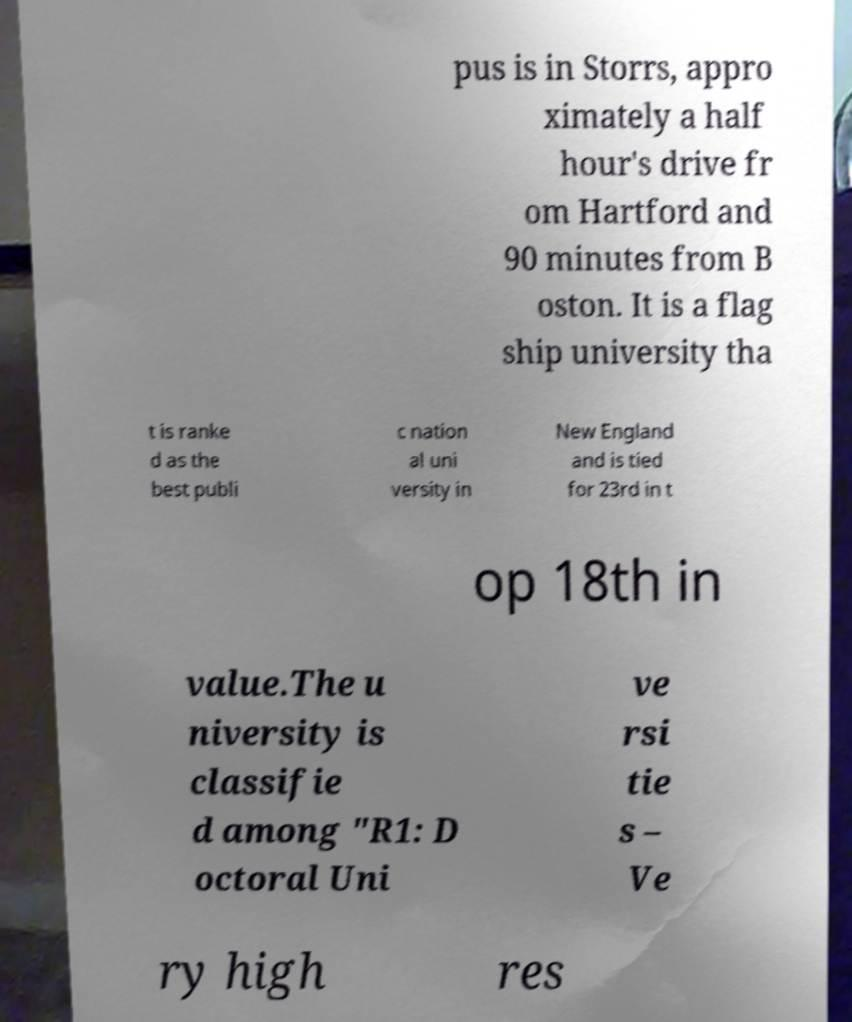Could you assist in decoding the text presented in this image and type it out clearly? pus is in Storrs, appro ximately a half hour's drive fr om Hartford and 90 minutes from B oston. It is a flag ship university tha t is ranke d as the best publi c nation al uni versity in New England and is tied for 23rd in t op 18th in value.The u niversity is classifie d among "R1: D octoral Uni ve rsi tie s – Ve ry high res 